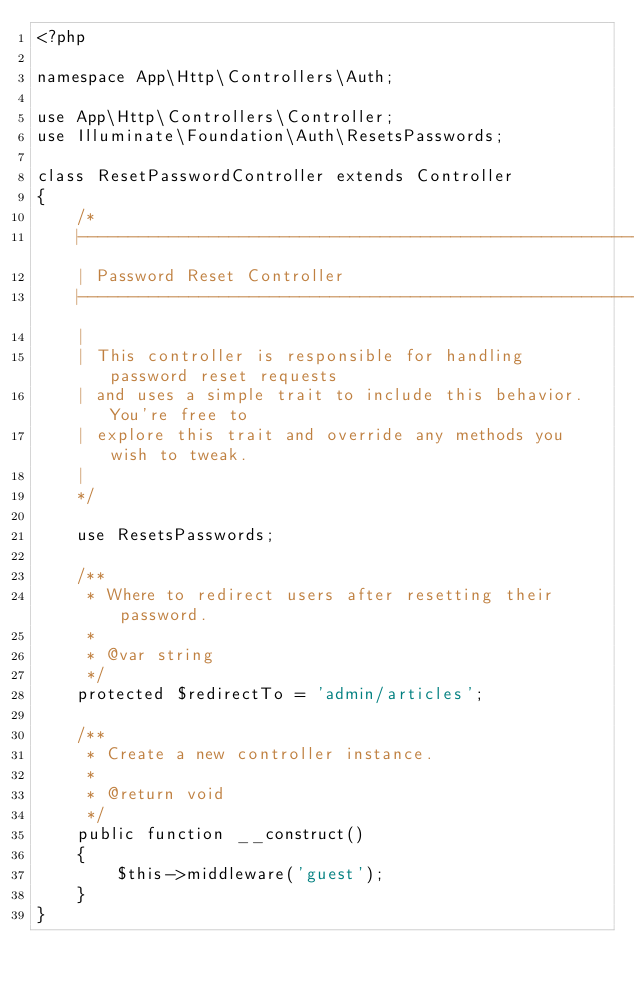Convert code to text. <code><loc_0><loc_0><loc_500><loc_500><_PHP_><?php

namespace App\Http\Controllers\Auth;

use App\Http\Controllers\Controller;
use Illuminate\Foundation\Auth\ResetsPasswords;

class ResetPasswordController extends Controller
{
    /*
    |--------------------------------------------------------------------------
    | Password Reset Controller
    |--------------------------------------------------------------------------
    |
    | This controller is responsible for handling password reset requests
    | and uses a simple trait to include this behavior. You're free to
    | explore this trait and override any methods you wish to tweak.
    |
    */

    use ResetsPasswords;

    /**
     * Where to redirect users after resetting their password.
     *
     * @var string
     */
    protected $redirectTo = 'admin/articles';

    /**
     * Create a new controller instance.
     *
     * @return void
     */
    public function __construct()
    {
        $this->middleware('guest');
    }
}
</code> 